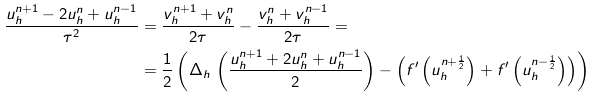Convert formula to latex. <formula><loc_0><loc_0><loc_500><loc_500>\frac { u _ { h } ^ { n + 1 } - 2 u _ { h } ^ { n } + u _ { h } ^ { n - 1 } } { \tau ^ { 2 } } & = \frac { v _ { h } ^ { n + 1 } + v _ { h } ^ { n } } { 2 \tau } - \frac { v _ { h } ^ { n } + v _ { h } ^ { n - 1 } } { 2 \tau } = \\ & = \frac { 1 } { 2 } \left ( \Delta _ { h } \, \left ( \frac { u _ { h } ^ { n + 1 } + 2 u _ { h } ^ { n } + u _ { h } ^ { n - 1 } } { 2 } \right ) - \left ( f ^ { \prime } \left ( u _ { h } ^ { n + \frac { 1 } { 2 } } \right ) + f ^ { \prime } \left ( u _ { h } ^ { n - \frac { 1 } { 2 } } \right ) \right ) \right )</formula> 